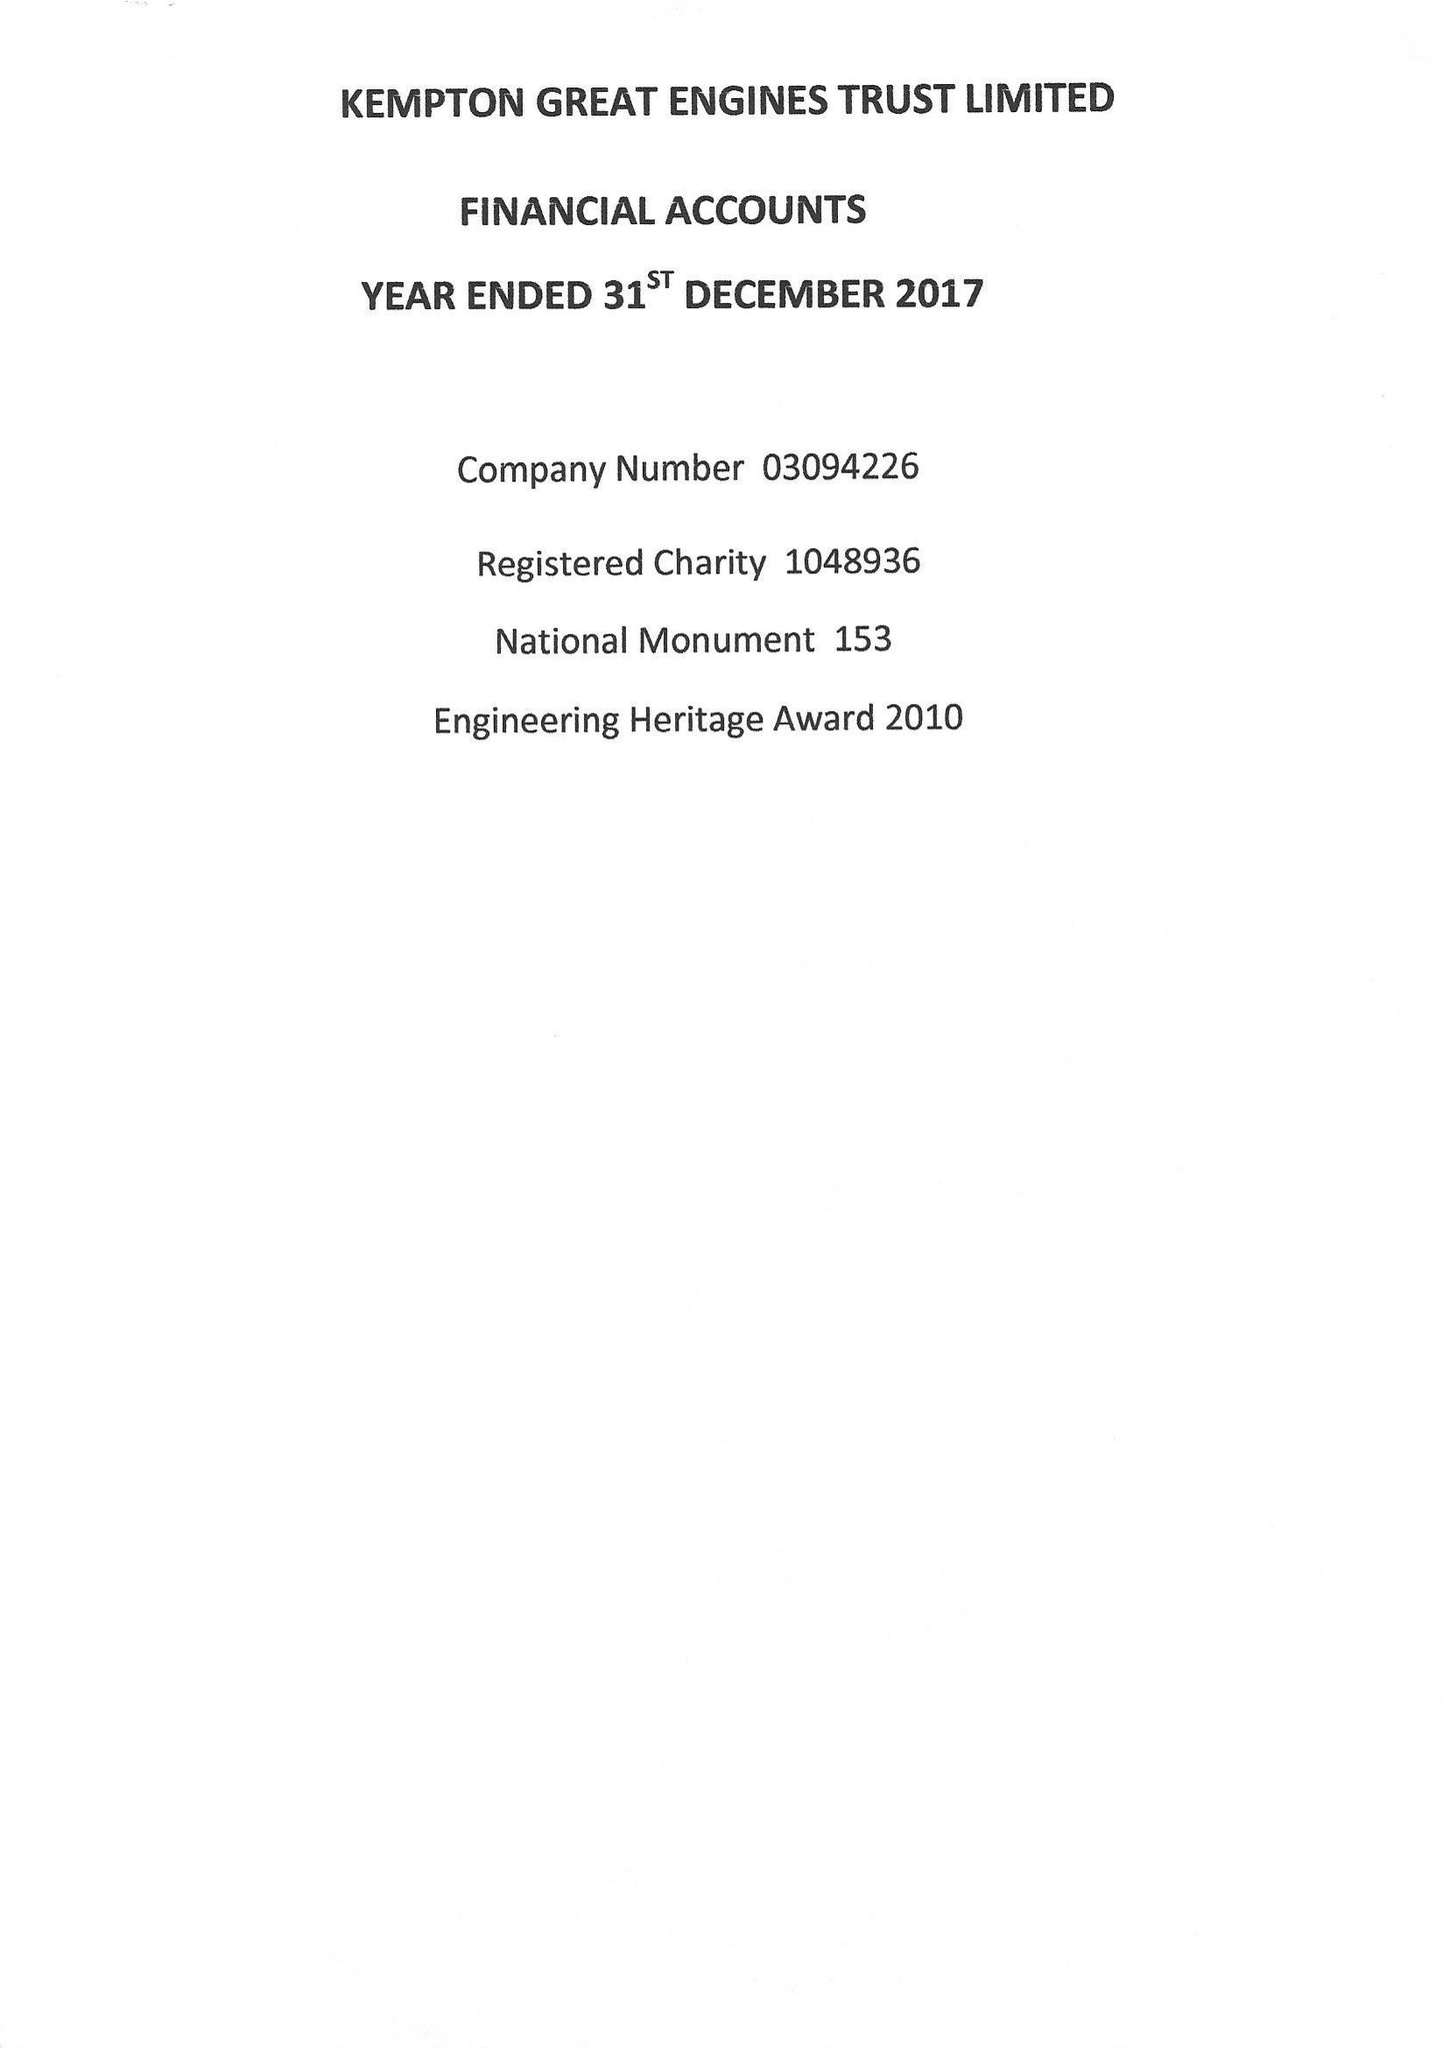What is the value for the income_annually_in_british_pounds?
Answer the question using a single word or phrase. 74370.00 